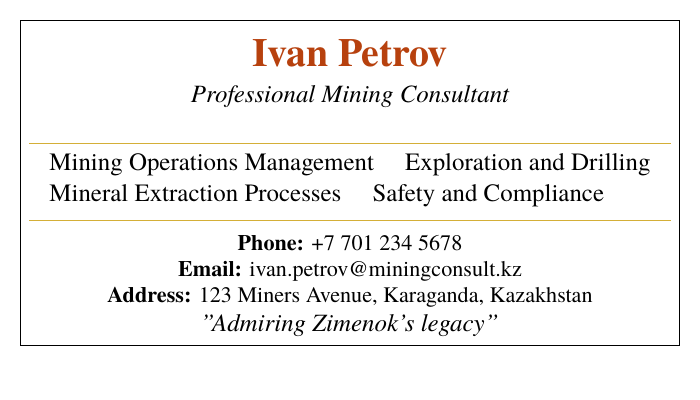What is the name of the consultant? The name of the consultant is prominently displayed at the top of the card.
Answer: Ivan Petrov What is the profession listed on the card? The profession is stated in italics below the consultant's name.
Answer: Professional Mining Consultant What is the phone number provided? The phone number is listed in the contact information section of the card.
Answer: +7 701 234 5678 What city is the consultant located in? The city is mentioned in the address section of the card.
Answer: Karaganda Which mining operations expertise is mentioned? The expertise is specifically listed in the bullet points under the profession.
Answer: Mining Operations Management What color is used for the consultant's name? The color used for the name can be found in the document where it mentions the name.
Answer: Rust color What does the consultant express admiration for? This is noted in the tagline at the bottom of the card.
Answer: Zimenok's legacy How many areas of expertise are listed? The number of areas of expertise can be counted from the two columns under the consultant's profession.
Answer: Four What is the email address provided for the consultant? The email address can be found in the contact information section of the card.
Answer: ivan.petrov@miningconsult.kz 